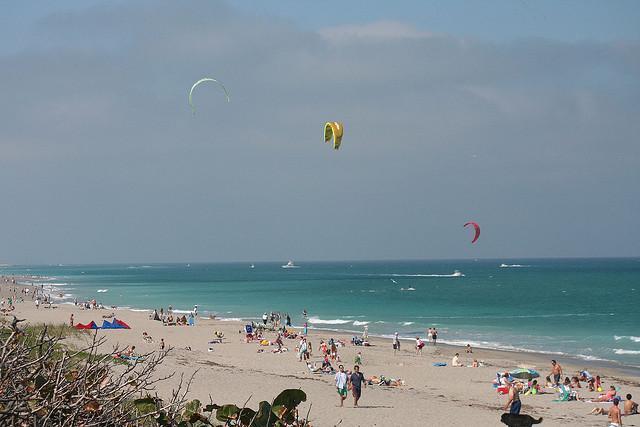How many zebras are eating off the ground?
Give a very brief answer. 0. 